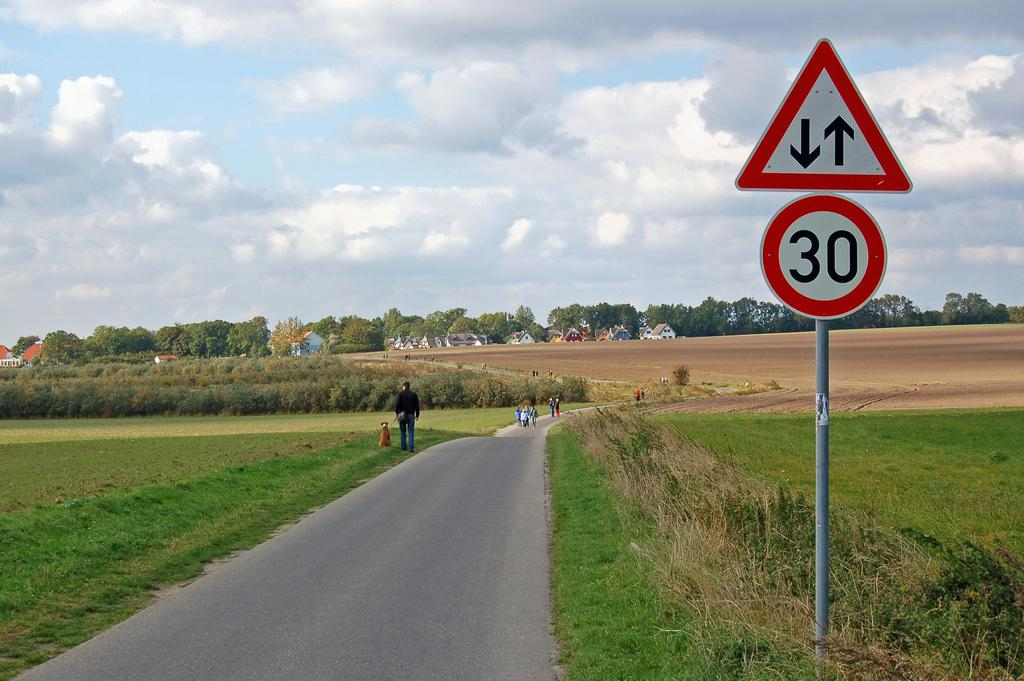<image>
Summarize the visual content of the image. a 30 sign is along a road going through a land of grass 